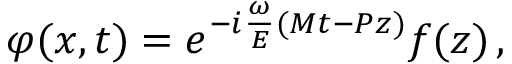Convert formula to latex. <formula><loc_0><loc_0><loc_500><loc_500>\varphi ( x , t ) = e ^ { - i \frac { \omega } { E } ( M t - P z ) } f ( z ) \, ,</formula> 